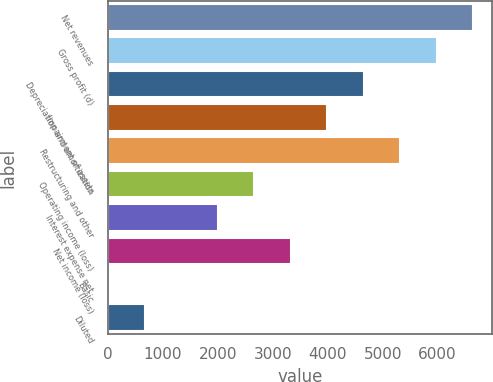<chart> <loc_0><loc_0><loc_500><loc_500><bar_chart><fcel>Net revenues<fcel>Gross profit (d)<fcel>Depreciation and amortization<fcel>Impairment of assets<fcel>Restructuring and other<fcel>Operating income (loss)<fcel>Interest expense net<fcel>Net income (loss)<fcel>Basic<fcel>Diluted<nl><fcel>6652.8<fcel>5987.64<fcel>4657.32<fcel>3992.16<fcel>5322.48<fcel>2661.84<fcel>1996.68<fcel>3327<fcel>1.2<fcel>666.36<nl></chart> 